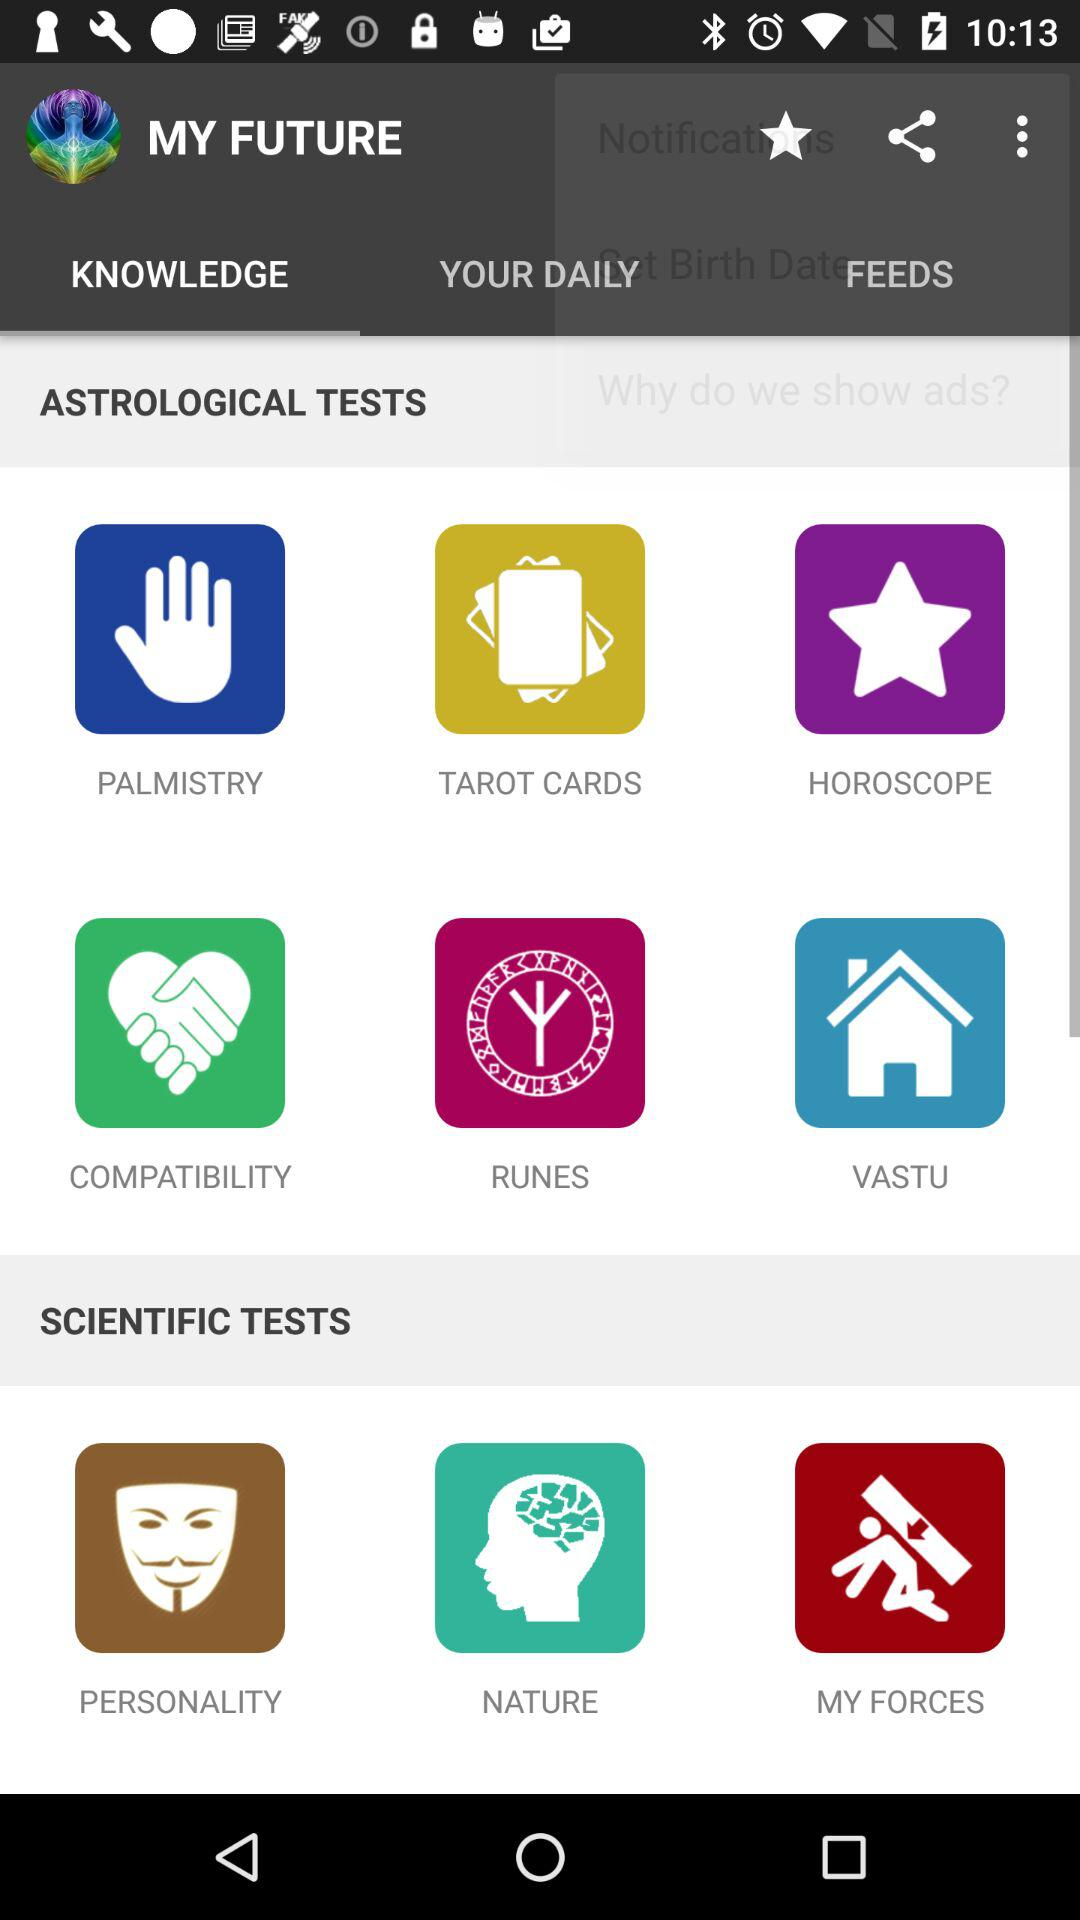How many tests are there in total?
Answer the question using a single word or phrase. 9 